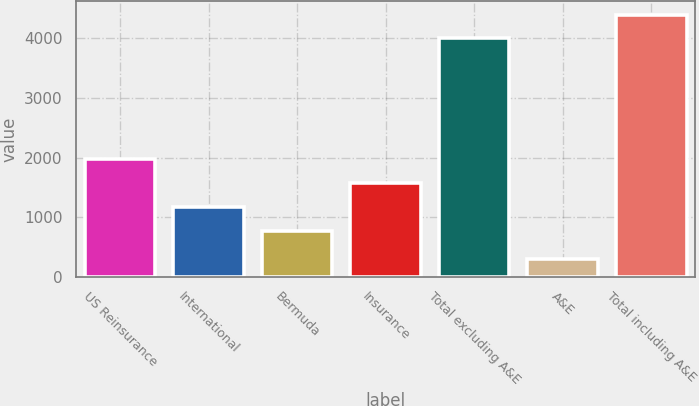Convert chart. <chart><loc_0><loc_0><loc_500><loc_500><bar_chart><fcel>US Reinsurance<fcel>International<fcel>Bermuda<fcel>Insurance<fcel>Total excluding A&E<fcel>A&E<fcel>Total including A&E<nl><fcel>1969.52<fcel>1169.84<fcel>770<fcel>1569.68<fcel>3998.4<fcel>293.5<fcel>4398.24<nl></chart> 